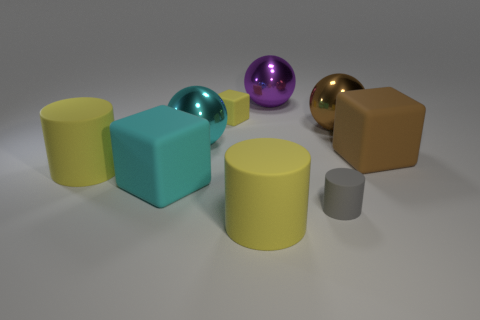Subtract all blocks. How many objects are left? 6 Subtract all small yellow rubber objects. Subtract all tiny matte things. How many objects are left? 6 Add 3 big purple metal objects. How many big purple metal objects are left? 4 Add 6 cyan spheres. How many cyan spheres exist? 7 Subtract 0 cyan cylinders. How many objects are left? 9 